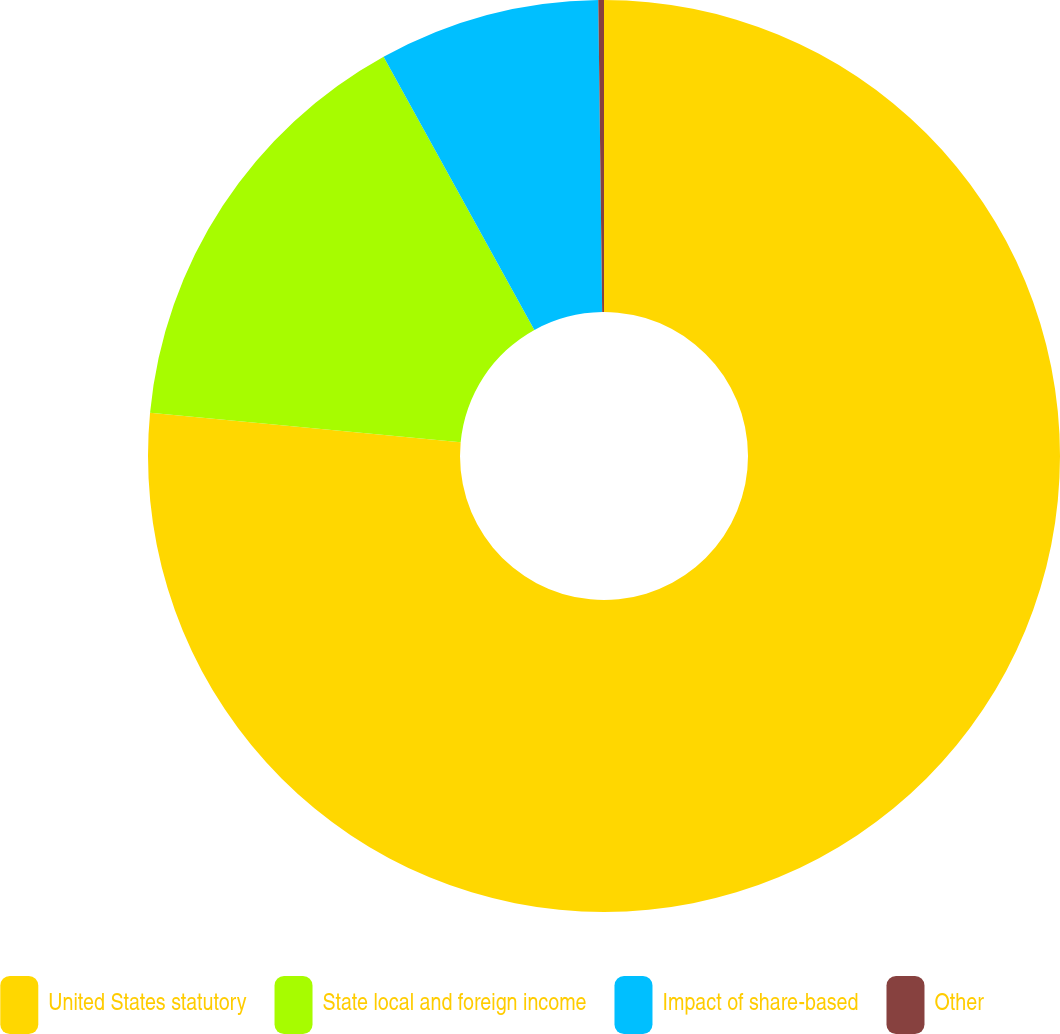<chart> <loc_0><loc_0><loc_500><loc_500><pie_chart><fcel>United States statutory<fcel>State local and foreign income<fcel>Impact of share-based<fcel>Other<nl><fcel>76.52%<fcel>15.46%<fcel>7.83%<fcel>0.2%<nl></chart> 